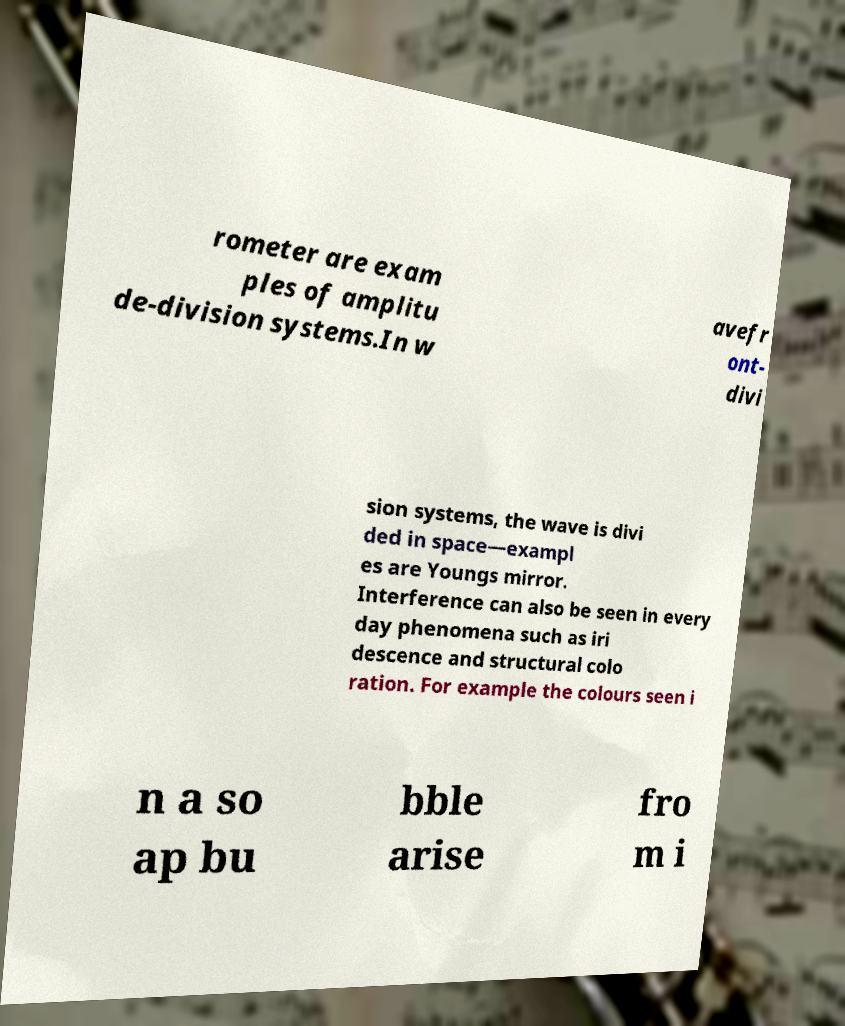Please identify and transcribe the text found in this image. rometer are exam ples of amplitu de-division systems.In w avefr ont- divi sion systems, the wave is divi ded in space—exampl es are Youngs mirror. Interference can also be seen in every day phenomena such as iri descence and structural colo ration. For example the colours seen i n a so ap bu bble arise fro m i 